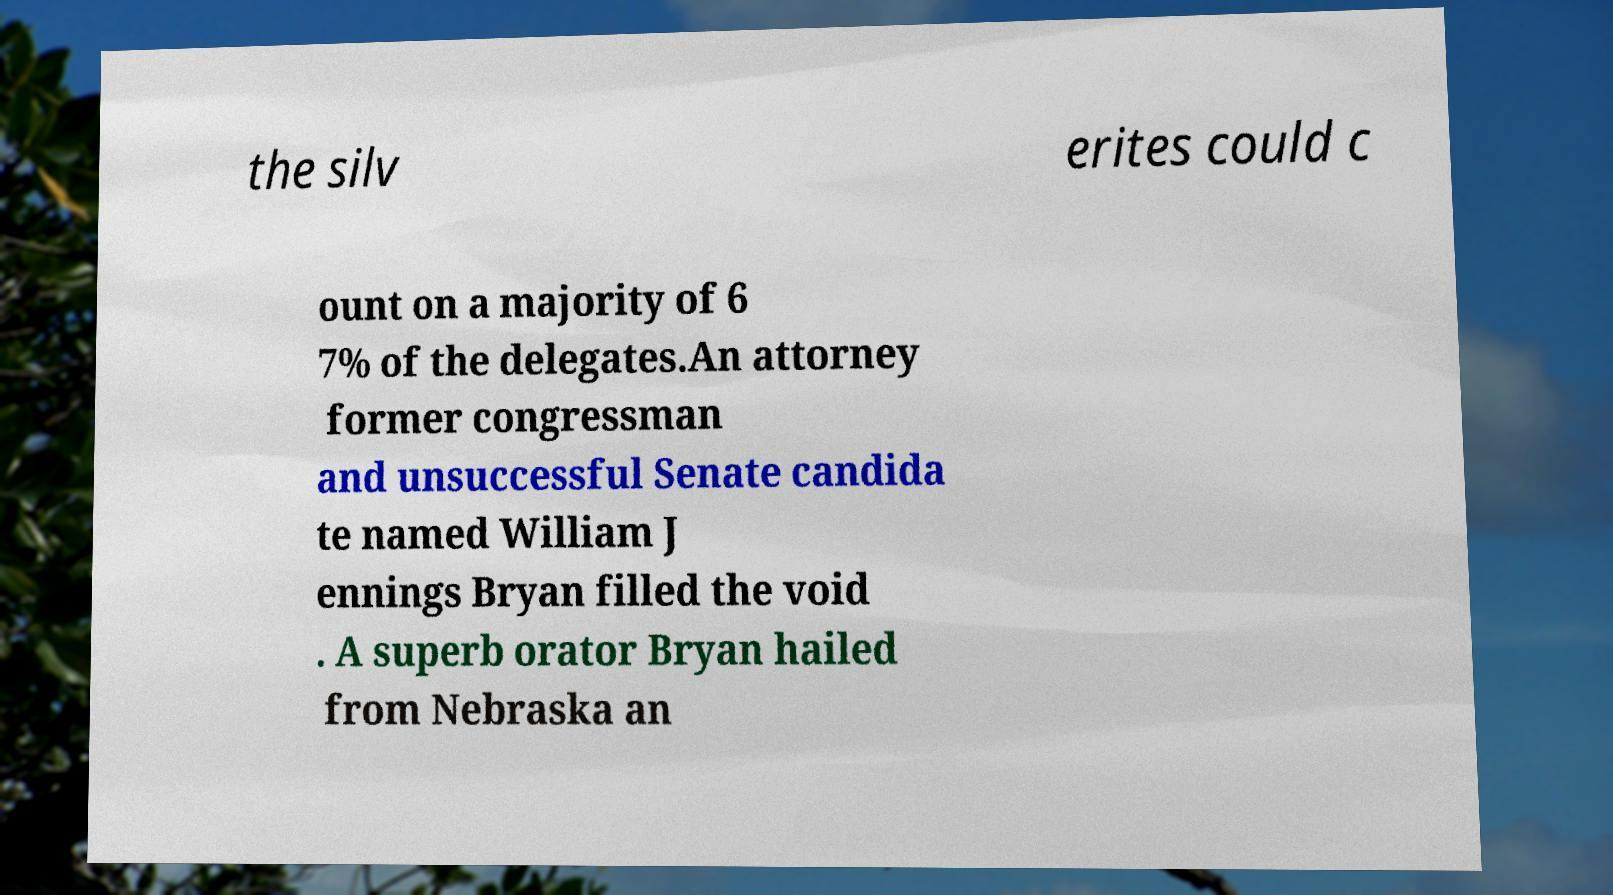What messages or text are displayed in this image? I need them in a readable, typed format. the silv erites could c ount on a majority of 6 7% of the delegates.An attorney former congressman and unsuccessful Senate candida te named William J ennings Bryan filled the void . A superb orator Bryan hailed from Nebraska an 